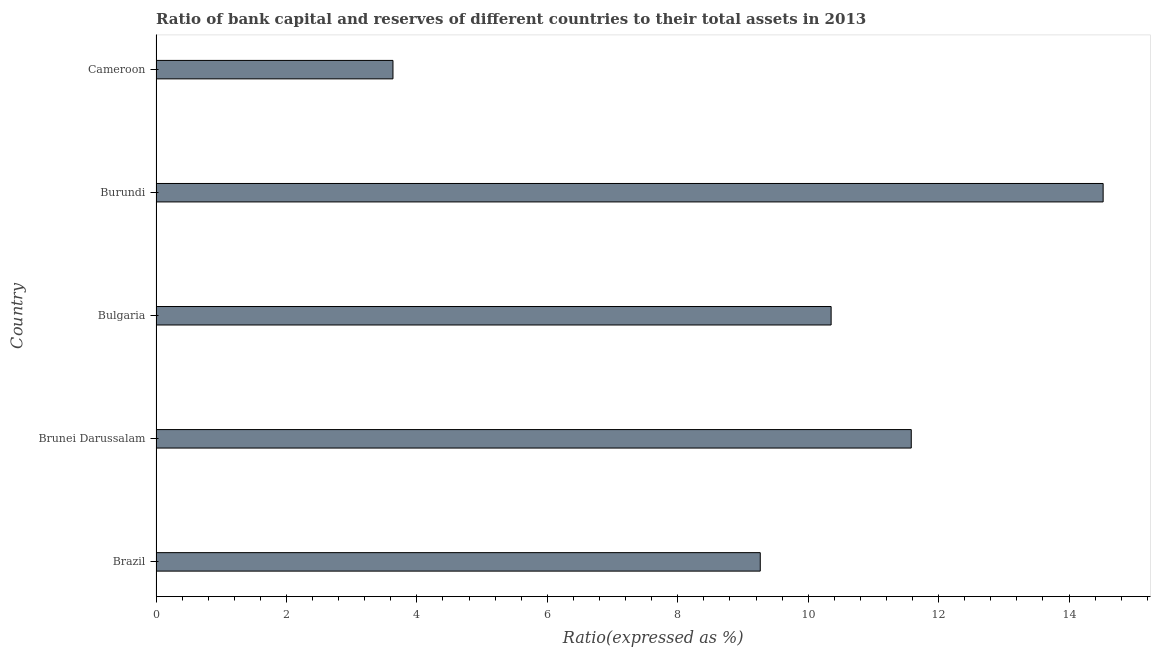Does the graph contain any zero values?
Give a very brief answer. No. What is the title of the graph?
Offer a terse response. Ratio of bank capital and reserves of different countries to their total assets in 2013. What is the label or title of the X-axis?
Keep it short and to the point. Ratio(expressed as %). What is the label or title of the Y-axis?
Your answer should be compact. Country. What is the bank capital to assets ratio in Cameroon?
Ensure brevity in your answer.  3.63. Across all countries, what is the maximum bank capital to assets ratio?
Your answer should be very brief. 14.52. Across all countries, what is the minimum bank capital to assets ratio?
Ensure brevity in your answer.  3.63. In which country was the bank capital to assets ratio maximum?
Make the answer very short. Burundi. In which country was the bank capital to assets ratio minimum?
Make the answer very short. Cameroon. What is the sum of the bank capital to assets ratio?
Your answer should be very brief. 49.35. What is the difference between the bank capital to assets ratio in Brazil and Brunei Darussalam?
Make the answer very short. -2.31. What is the average bank capital to assets ratio per country?
Offer a very short reply. 9.87. What is the median bank capital to assets ratio?
Offer a very short reply. 10.35. In how many countries, is the bank capital to assets ratio greater than 8.8 %?
Your answer should be compact. 4. What is the ratio of the bank capital to assets ratio in Brunei Darussalam to that in Bulgaria?
Your answer should be compact. 1.12. Is the bank capital to assets ratio in Brazil less than that in Brunei Darussalam?
Offer a terse response. Yes. What is the difference between the highest and the second highest bank capital to assets ratio?
Give a very brief answer. 2.94. Is the sum of the bank capital to assets ratio in Burundi and Cameroon greater than the maximum bank capital to assets ratio across all countries?
Provide a short and direct response. Yes. What is the difference between the highest and the lowest bank capital to assets ratio?
Ensure brevity in your answer.  10.89. How many bars are there?
Your answer should be very brief. 5. Are all the bars in the graph horizontal?
Provide a succinct answer. Yes. How many countries are there in the graph?
Make the answer very short. 5. What is the Ratio(expressed as %) in Brazil?
Ensure brevity in your answer.  9.27. What is the Ratio(expressed as %) of Brunei Darussalam?
Keep it short and to the point. 11.58. What is the Ratio(expressed as %) of Bulgaria?
Give a very brief answer. 10.35. What is the Ratio(expressed as %) in Burundi?
Make the answer very short. 14.52. What is the Ratio(expressed as %) in Cameroon?
Provide a short and direct response. 3.63. What is the difference between the Ratio(expressed as %) in Brazil and Brunei Darussalam?
Your answer should be compact. -2.32. What is the difference between the Ratio(expressed as %) in Brazil and Bulgaria?
Give a very brief answer. -1.09. What is the difference between the Ratio(expressed as %) in Brazil and Burundi?
Your answer should be very brief. -5.26. What is the difference between the Ratio(expressed as %) in Brazil and Cameroon?
Provide a succinct answer. 5.63. What is the difference between the Ratio(expressed as %) in Brunei Darussalam and Bulgaria?
Your answer should be compact. 1.23. What is the difference between the Ratio(expressed as %) in Brunei Darussalam and Burundi?
Your response must be concise. -2.94. What is the difference between the Ratio(expressed as %) in Brunei Darussalam and Cameroon?
Keep it short and to the point. 7.95. What is the difference between the Ratio(expressed as %) in Bulgaria and Burundi?
Make the answer very short. -4.17. What is the difference between the Ratio(expressed as %) in Bulgaria and Cameroon?
Offer a terse response. 6.72. What is the difference between the Ratio(expressed as %) in Burundi and Cameroon?
Offer a very short reply. 10.89. What is the ratio of the Ratio(expressed as %) in Brazil to that in Brunei Darussalam?
Make the answer very short. 0.8. What is the ratio of the Ratio(expressed as %) in Brazil to that in Bulgaria?
Give a very brief answer. 0.9. What is the ratio of the Ratio(expressed as %) in Brazil to that in Burundi?
Your answer should be compact. 0.64. What is the ratio of the Ratio(expressed as %) in Brazil to that in Cameroon?
Your answer should be compact. 2.55. What is the ratio of the Ratio(expressed as %) in Brunei Darussalam to that in Bulgaria?
Your answer should be compact. 1.12. What is the ratio of the Ratio(expressed as %) in Brunei Darussalam to that in Burundi?
Provide a succinct answer. 0.8. What is the ratio of the Ratio(expressed as %) in Brunei Darussalam to that in Cameroon?
Your answer should be very brief. 3.19. What is the ratio of the Ratio(expressed as %) in Bulgaria to that in Burundi?
Ensure brevity in your answer.  0.71. What is the ratio of the Ratio(expressed as %) in Bulgaria to that in Cameroon?
Provide a short and direct response. 2.85. What is the ratio of the Ratio(expressed as %) in Burundi to that in Cameroon?
Give a very brief answer. 4. 